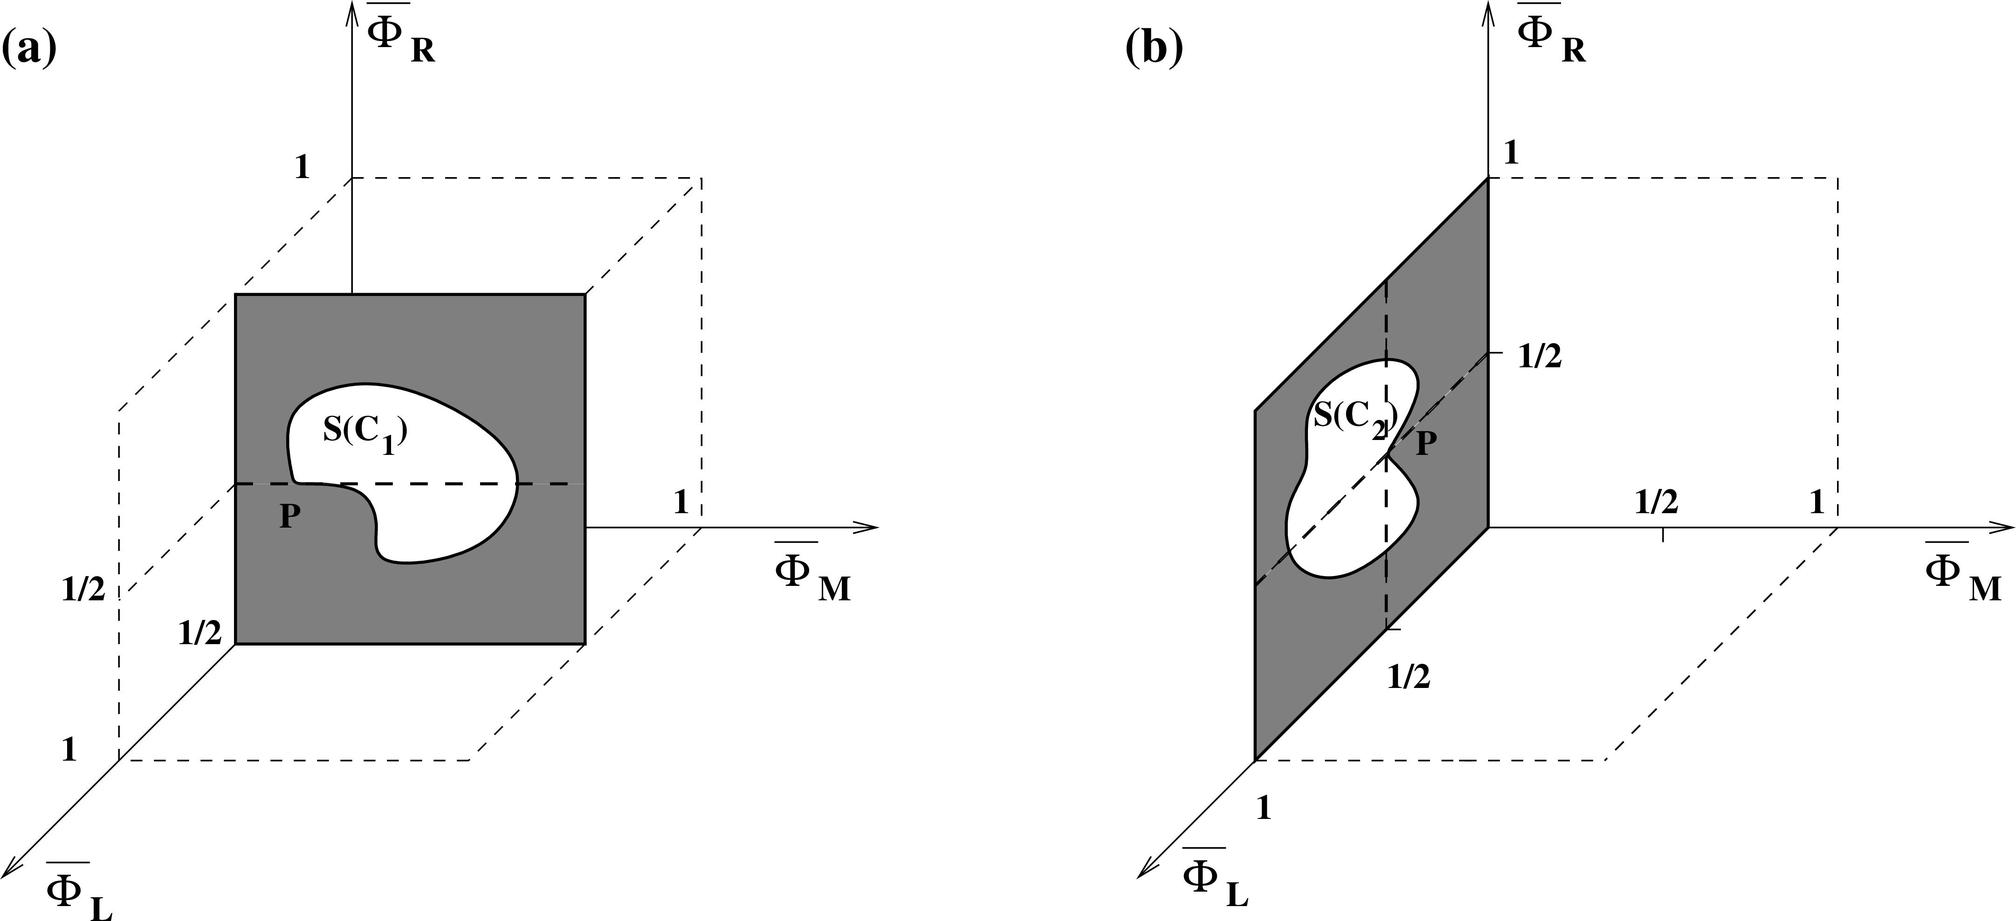In the context of the given figures, which statement accurately describes the relationship between Φ_M and Φ_R? A. Φ_M is directly proportional to Φ_R. B. Φ_M is inversely proportional to Φ_R. C. Φ_M and Φ_R are independent. D. Φ_M and Φ_R are the same in both figures. From the figures, we can see that the dimensions for Φ_M and Φ_R are represented on perpendicular axes, suggesting that they are independent variables in this context. Therefore, the correct answer is C. 